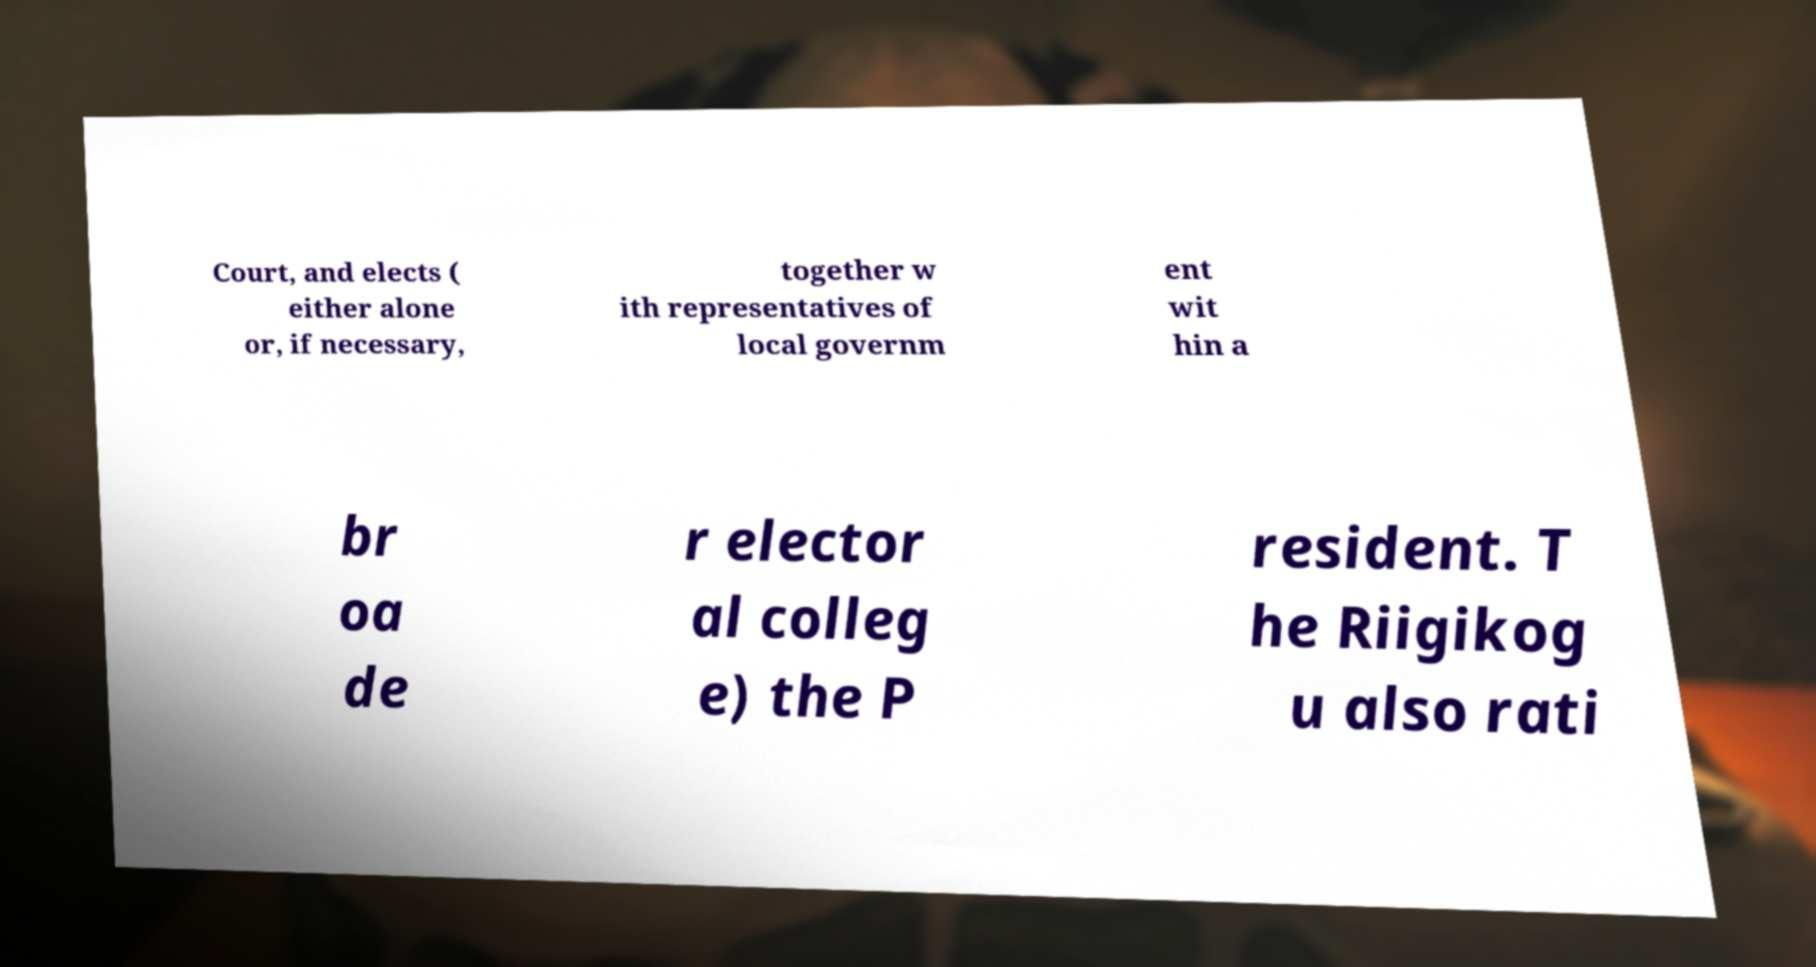Can you accurately transcribe the text from the provided image for me? Court, and elects ( either alone or, if necessary, together w ith representatives of local governm ent wit hin a br oa de r elector al colleg e) the P resident. T he Riigikog u also rati 